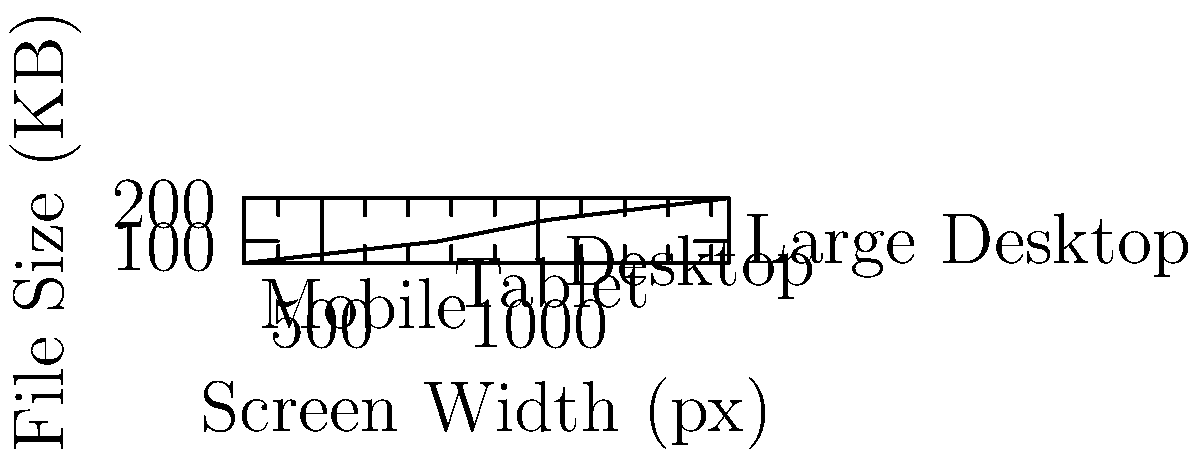Based on the graph showing the relationship between screen width and image file size for responsive design, what technique is being illustrated for optimizing images across different device sizes? 1. The graph shows a positive correlation between screen width and file size.
2. As the screen width increases, the file size of the image also increases.
3. This relationship is divided into four distinct segments:
   - Mobile (320px): 50KB
   - Tablet (768px): 100KB
   - Desktop (1024px): 150KB
   - Large Desktop (1440px): 200KB
4. This pattern indicates that different image versions are being served based on the screen size.
5. The technique illustrated is known as "responsive images" or "adaptive images."
6. In this approach, multiple versions of an image are created, each optimized for a specific screen size range.
7. The appropriate image version is then served to the user based on their device's screen width.
8. This technique helps to balance image quality and file size, ensuring faster load times on smaller devices while providing higher quality images for larger screens.
Answer: Responsive images 